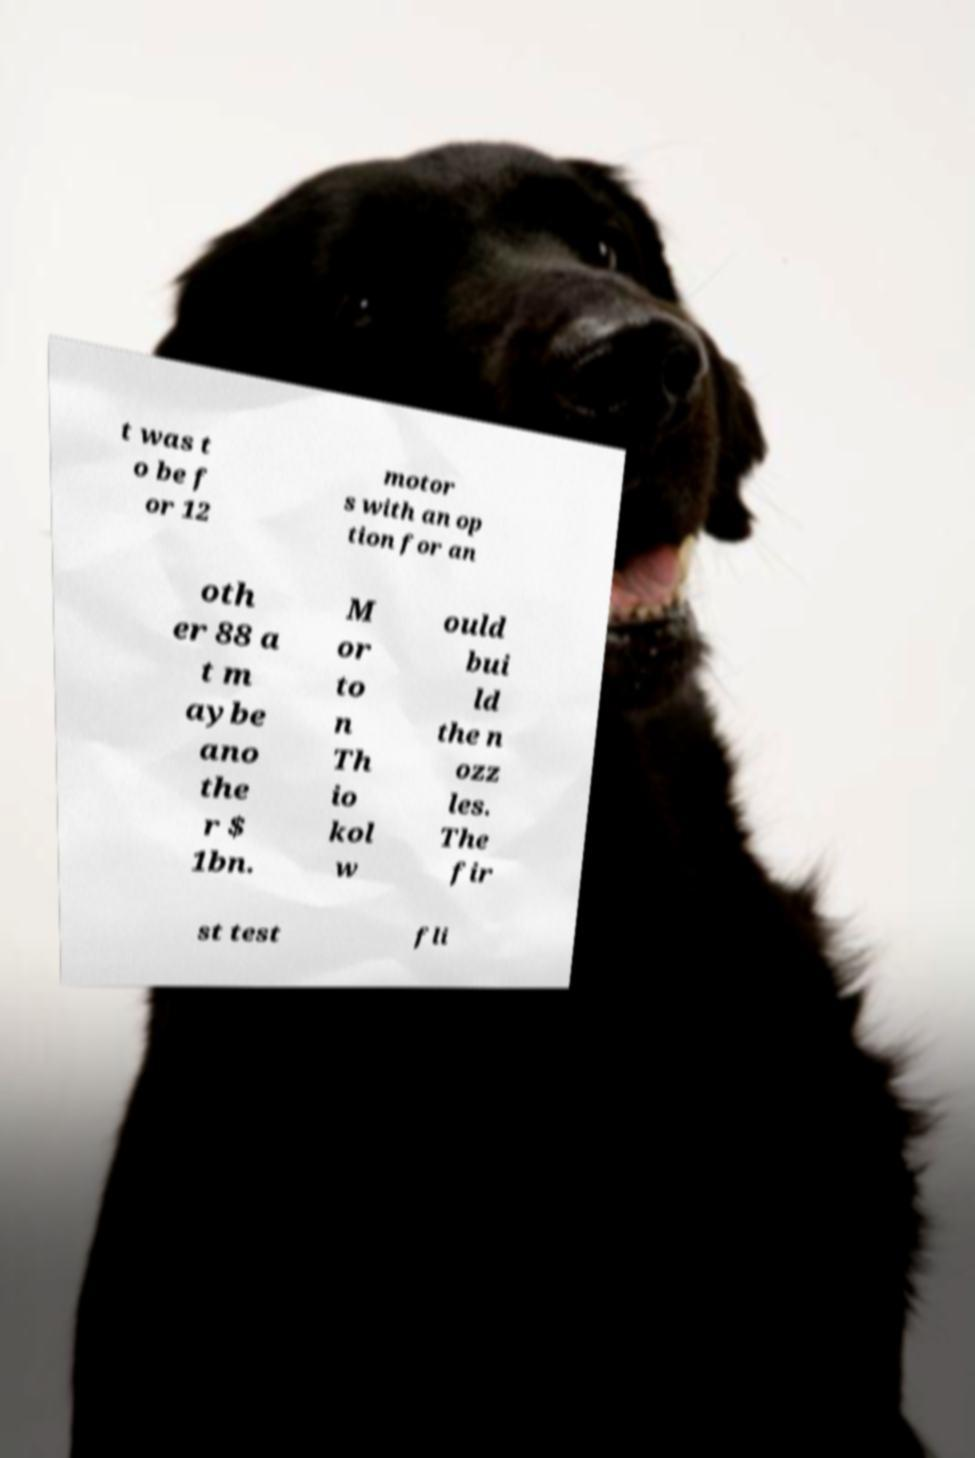Please read and relay the text visible in this image. What does it say? t was t o be f or 12 motor s with an op tion for an oth er 88 a t m aybe ano the r $ 1bn. M or to n Th io kol w ould bui ld the n ozz les. The fir st test fli 